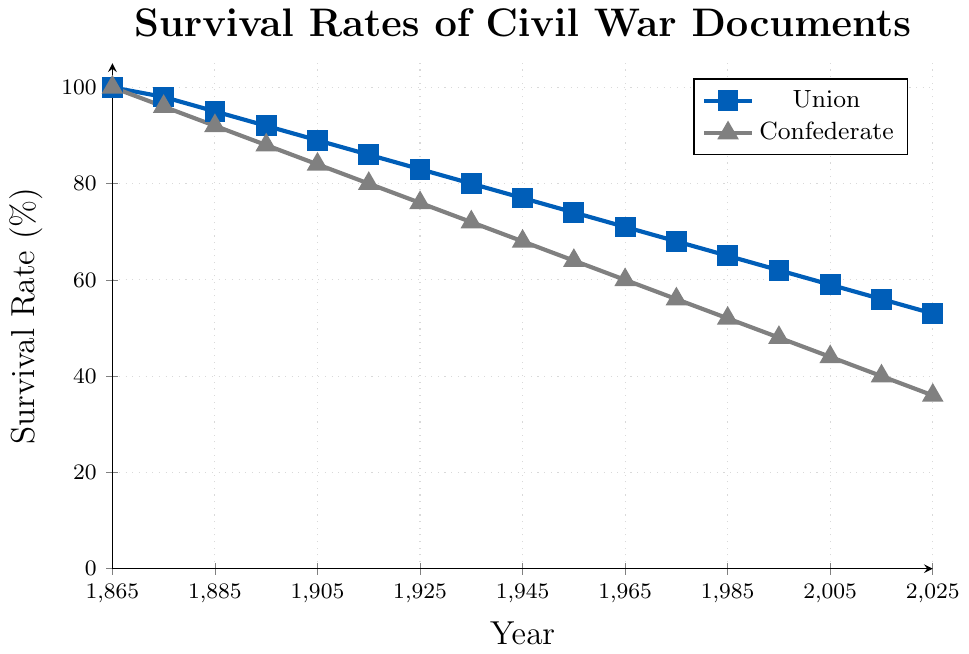When does the Union survival rate drop below 60%? We observe the line representing the Union's survival rate. The value drops below 60% between 1995 and 2005. By looking at the data points, in 2005 it is 59%, thus the Union survival rate drops below 60% in 2005.
Answer: 2005 How much lower is the Confederate survival rate compared to the Union rate in 2015? Find the survival rates for both the Union and Confederate in 2015. The Union rate is 56%, and the Confederate rate is 40%. The difference is obtained by subtracting the Confederate rate from the Union rate: 56% - 40% = 16%.
Answer: 16% Approximately how many years later did the Confederate survival rate reach 50% compared to the Union rate? Find the years when the rates for Union and Confederate are close to 50%. For the Union, it is around 1995 (62%) and for the Confederate, it is around 1985 (52%). The difference is 1995 - 1985 = 10 years.
Answer: 10 years What is the average survival rate for Confederate documents between 1945 and 1965? Identify the survival rates for Confederate documents in 1945, 1955, and 1965, which are 68%, 64%, and 60%, respectively. Then calculate the average: (68 + 64 + 60) / 3 = 64%.
Answer: 64% Which side shows a steeper decline in survival rates between 1865 and 1915? Look at the slopes of the two lines from 1865 to 1915. The Union line decreases from 100% to 86%, a decline of 14%. The Confederate line decreases from 100% to 80%, a decline of 20%. Hence, the Confederate side shows a steeper decline.
Answer: Confederate In which year was the survival rate the same for both Union and Confederate documents? Check for any years where the lines intersect, indicating the same survival rate for both. The lines do not intersect; thus, there is no such year where the survival rates were the same.
Answer: None How does the decline in survival rates from 1925 to 2025 compare for Union and Confederate documents? Calculate the decline for both from 1925 to 2025. For Union, it goes from 83% to 53%, a decline of 30%. For Confederate, it goes from 76% to 36%, a decline of 40%. Thus, Confederate documents decline 10% more than Union documents in this period.
Answer: Union: 30%, Confederate: 40% What is the survival rate trend from 1865 to 2025 for both Union and Confederate documents? Observing the lines, both Union and Confederate documents show a consistent decline from 100% in 1865 to 53% (Union) and 36% (Confederate) in 2025, indicating a steady decrease across both categories.
Answer: Steady decline During which decade does the Union survival rate drop below 80%? Look for the year when the Union rate first dips below 80%. This occurs around 1935 when it is exactly 80% and drops to 77% in 1945. Hence, the decade is the 1930s.
Answer: 1930s 